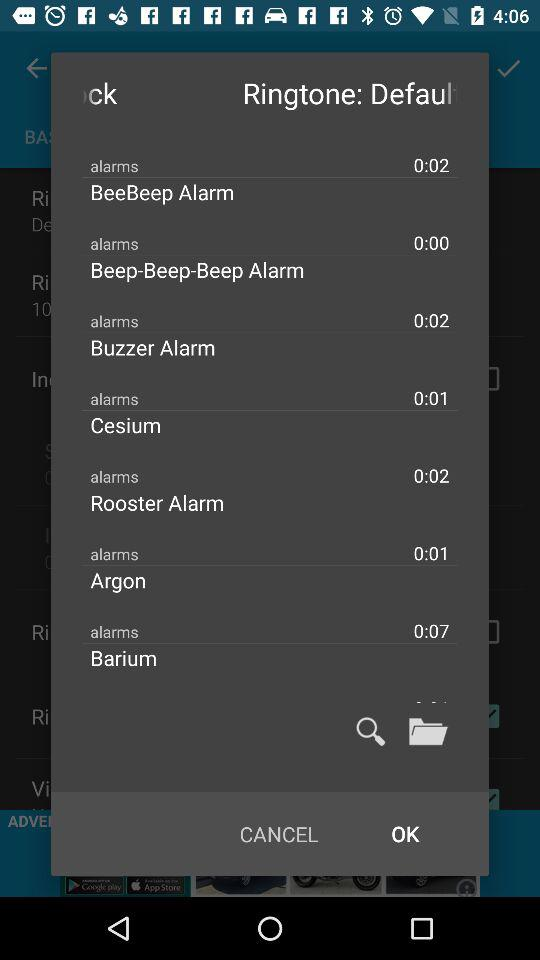Which alarm has a length of 0:07? The alarm is "Barium". 